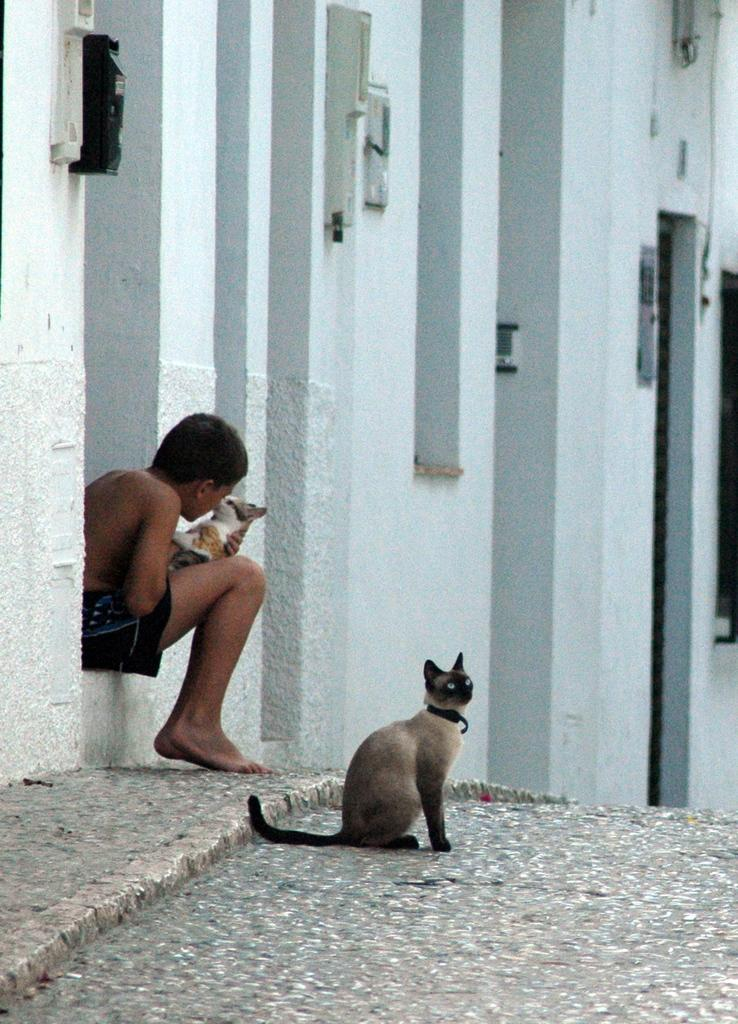Who is the main subject in the image? There is a boy in the image. What is the boy doing in the image? The boy is sitting on a wall. What is the boy holding in his hand? The boy is holding a cat in his hand. What else can be seen in the image related to cats? There is a cat on a path in front of the boy. What is visible in the background of the image? There is a wall in the background of the image. What type of hammer is the boy using to hit the zinc in the image? There is no hammer or zinc present in the image. How many kittens can be seen playing with the boy in the image? There is only one cat visible in the image, and it is being held by the boy. There are no kittens present. 